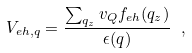Convert formula to latex. <formula><loc_0><loc_0><loc_500><loc_500>V _ { e h , q } = \frac { \sum _ { q _ { z } } v _ { Q } f _ { e h } ( q _ { z } ) } { \epsilon ( { q } ) } \ ,</formula> 